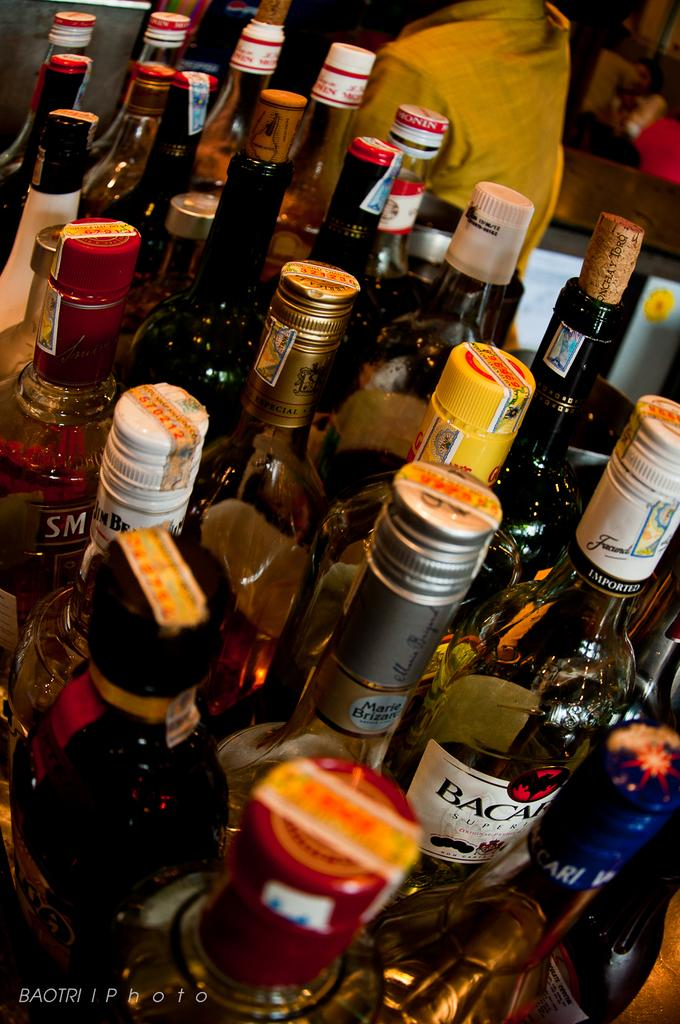<image>
Present a compact description of the photo's key features. A bottle of Bacardi has the word imported towards the top of the bottle. 